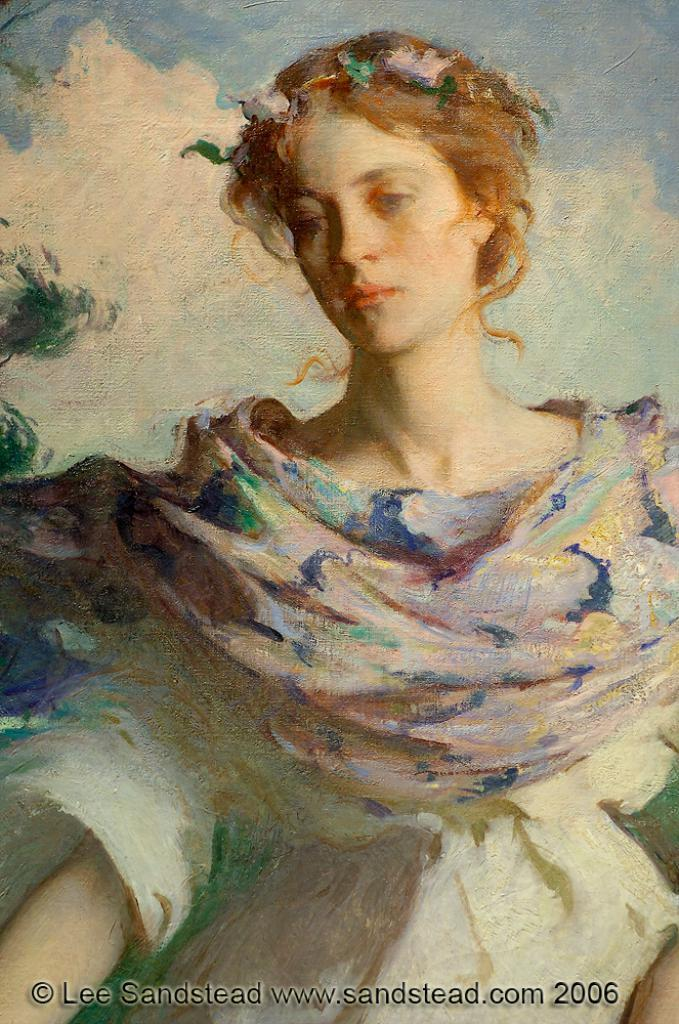What is the main subject of the image? There is a painting in the image. Can you describe the painting in the image? Unfortunately, the provided facts do not give any details about the painting, so it cannot be described. What is the level of disgust expressed by the painting in the image? There is no indication of any emotion, including disgust, in the painting, as it is a static image and cannot express emotions. 